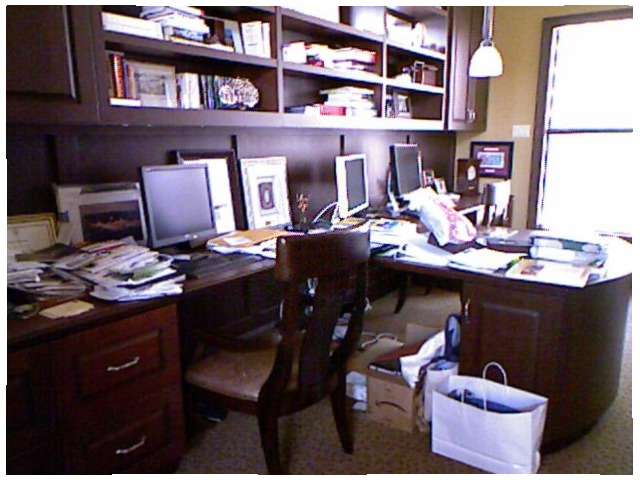<image>
Can you confirm if the book is on the shelf? Yes. Looking at the image, I can see the book is positioned on top of the shelf, with the shelf providing support. Where is the laptop in relation to the table? Is it on the table? Yes. Looking at the image, I can see the laptop is positioned on top of the table, with the table providing support. Is the computer on the desk? No. The computer is not positioned on the desk. They may be near each other, but the computer is not supported by or resting on top of the desk. Where is the monitor in relation to the desk? Is it on the desk? No. The monitor is not positioned on the desk. They may be near each other, but the monitor is not supported by or resting on top of the desk. Where is the shopping bag in relation to the chair? Is it on the chair? No. The shopping bag is not positioned on the chair. They may be near each other, but the shopping bag is not supported by or resting on top of the chair. Where is the chair in relation to the desk? Is it next to the desk? No. The chair is not positioned next to the desk. They are located in different areas of the scene. 